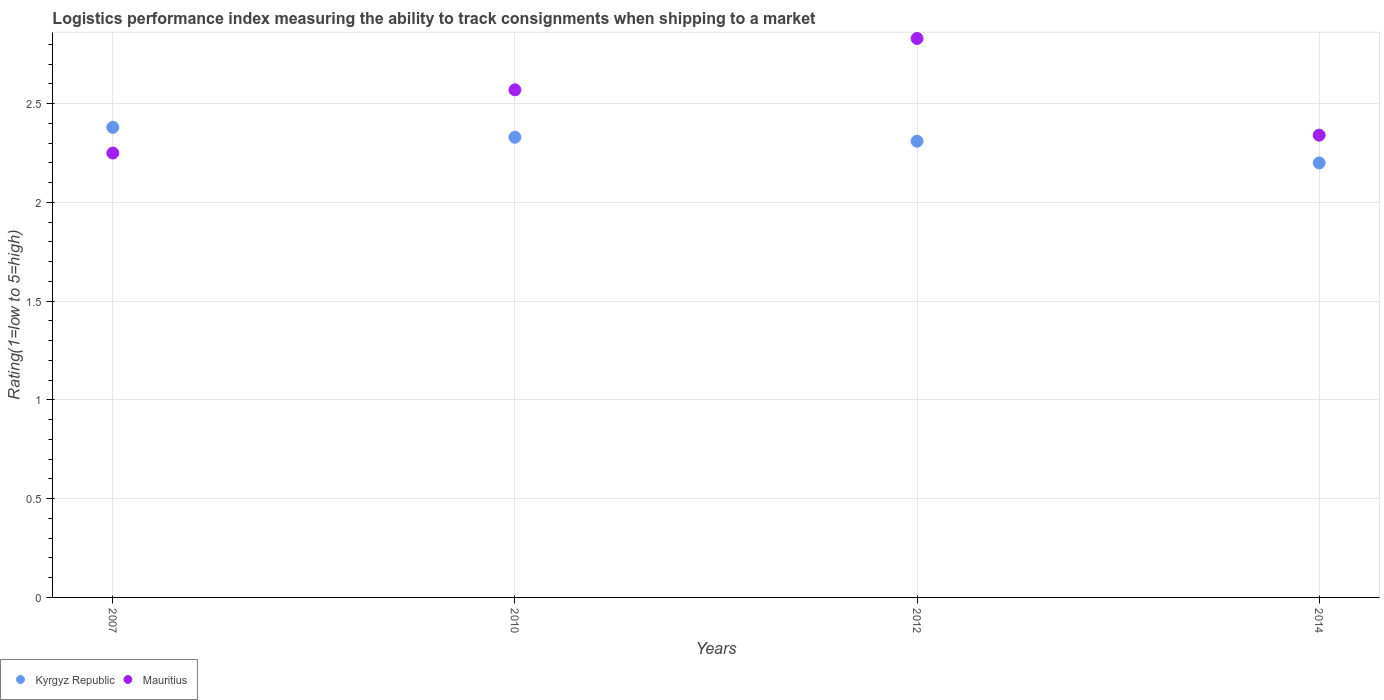Is the number of dotlines equal to the number of legend labels?
Keep it short and to the point. Yes. What is the Logistic performance index in Mauritius in 2007?
Your response must be concise. 2.25. Across all years, what is the maximum Logistic performance index in Kyrgyz Republic?
Ensure brevity in your answer.  2.38. Across all years, what is the minimum Logistic performance index in Kyrgyz Republic?
Your answer should be very brief. 2.2. In which year was the Logistic performance index in Kyrgyz Republic maximum?
Make the answer very short. 2007. In which year was the Logistic performance index in Mauritius minimum?
Provide a succinct answer. 2007. What is the total Logistic performance index in Mauritius in the graph?
Give a very brief answer. 9.99. What is the difference between the Logistic performance index in Kyrgyz Republic in 2010 and that in 2012?
Keep it short and to the point. 0.02. What is the difference between the Logistic performance index in Kyrgyz Republic in 2014 and the Logistic performance index in Mauritius in 2007?
Ensure brevity in your answer.  -0.05. What is the average Logistic performance index in Kyrgyz Republic per year?
Your answer should be very brief. 2.3. In the year 2014, what is the difference between the Logistic performance index in Kyrgyz Republic and Logistic performance index in Mauritius?
Give a very brief answer. -0.14. What is the ratio of the Logistic performance index in Mauritius in 2007 to that in 2012?
Give a very brief answer. 0.8. Is the Logistic performance index in Mauritius in 2012 less than that in 2014?
Your response must be concise. No. Is the difference between the Logistic performance index in Kyrgyz Republic in 2010 and 2012 greater than the difference between the Logistic performance index in Mauritius in 2010 and 2012?
Make the answer very short. Yes. What is the difference between the highest and the second highest Logistic performance index in Mauritius?
Your answer should be very brief. 0.26. What is the difference between the highest and the lowest Logistic performance index in Kyrgyz Republic?
Provide a succinct answer. 0.18. In how many years, is the Logistic performance index in Kyrgyz Republic greater than the average Logistic performance index in Kyrgyz Republic taken over all years?
Make the answer very short. 3. Does the Logistic performance index in Kyrgyz Republic monotonically increase over the years?
Your response must be concise. No. Is the Logistic performance index in Kyrgyz Republic strictly less than the Logistic performance index in Mauritius over the years?
Provide a succinct answer. No. How many dotlines are there?
Your answer should be compact. 2. How many years are there in the graph?
Provide a succinct answer. 4. Does the graph contain grids?
Make the answer very short. Yes. Where does the legend appear in the graph?
Provide a succinct answer. Bottom left. What is the title of the graph?
Give a very brief answer. Logistics performance index measuring the ability to track consignments when shipping to a market. What is the label or title of the Y-axis?
Give a very brief answer. Rating(1=low to 5=high). What is the Rating(1=low to 5=high) of Kyrgyz Republic in 2007?
Make the answer very short. 2.38. What is the Rating(1=low to 5=high) of Mauritius in 2007?
Your answer should be compact. 2.25. What is the Rating(1=low to 5=high) of Kyrgyz Republic in 2010?
Keep it short and to the point. 2.33. What is the Rating(1=low to 5=high) in Mauritius in 2010?
Your answer should be very brief. 2.57. What is the Rating(1=low to 5=high) of Kyrgyz Republic in 2012?
Keep it short and to the point. 2.31. What is the Rating(1=low to 5=high) of Mauritius in 2012?
Offer a terse response. 2.83. What is the Rating(1=low to 5=high) in Kyrgyz Republic in 2014?
Your answer should be very brief. 2.2. What is the Rating(1=low to 5=high) in Mauritius in 2014?
Make the answer very short. 2.34. Across all years, what is the maximum Rating(1=low to 5=high) of Kyrgyz Republic?
Offer a terse response. 2.38. Across all years, what is the maximum Rating(1=low to 5=high) in Mauritius?
Keep it short and to the point. 2.83. Across all years, what is the minimum Rating(1=low to 5=high) in Kyrgyz Republic?
Give a very brief answer. 2.2. Across all years, what is the minimum Rating(1=low to 5=high) of Mauritius?
Provide a short and direct response. 2.25. What is the total Rating(1=low to 5=high) of Kyrgyz Republic in the graph?
Make the answer very short. 9.22. What is the total Rating(1=low to 5=high) of Mauritius in the graph?
Give a very brief answer. 9.99. What is the difference between the Rating(1=low to 5=high) of Mauritius in 2007 and that in 2010?
Provide a short and direct response. -0.32. What is the difference between the Rating(1=low to 5=high) in Kyrgyz Republic in 2007 and that in 2012?
Your answer should be compact. 0.07. What is the difference between the Rating(1=low to 5=high) in Mauritius in 2007 and that in 2012?
Your answer should be very brief. -0.58. What is the difference between the Rating(1=low to 5=high) in Kyrgyz Republic in 2007 and that in 2014?
Offer a terse response. 0.18. What is the difference between the Rating(1=low to 5=high) of Mauritius in 2007 and that in 2014?
Ensure brevity in your answer.  -0.09. What is the difference between the Rating(1=low to 5=high) of Kyrgyz Republic in 2010 and that in 2012?
Offer a very short reply. 0.02. What is the difference between the Rating(1=low to 5=high) in Mauritius in 2010 and that in 2012?
Make the answer very short. -0.26. What is the difference between the Rating(1=low to 5=high) in Kyrgyz Republic in 2010 and that in 2014?
Provide a succinct answer. 0.13. What is the difference between the Rating(1=low to 5=high) in Mauritius in 2010 and that in 2014?
Give a very brief answer. 0.23. What is the difference between the Rating(1=low to 5=high) of Kyrgyz Republic in 2012 and that in 2014?
Your answer should be very brief. 0.11. What is the difference between the Rating(1=low to 5=high) in Mauritius in 2012 and that in 2014?
Keep it short and to the point. 0.49. What is the difference between the Rating(1=low to 5=high) of Kyrgyz Republic in 2007 and the Rating(1=low to 5=high) of Mauritius in 2010?
Make the answer very short. -0.19. What is the difference between the Rating(1=low to 5=high) of Kyrgyz Republic in 2007 and the Rating(1=low to 5=high) of Mauritius in 2012?
Give a very brief answer. -0.45. What is the difference between the Rating(1=low to 5=high) in Kyrgyz Republic in 2007 and the Rating(1=low to 5=high) in Mauritius in 2014?
Give a very brief answer. 0.04. What is the difference between the Rating(1=low to 5=high) in Kyrgyz Republic in 2010 and the Rating(1=low to 5=high) in Mauritius in 2014?
Keep it short and to the point. -0.01. What is the difference between the Rating(1=low to 5=high) in Kyrgyz Republic in 2012 and the Rating(1=low to 5=high) in Mauritius in 2014?
Ensure brevity in your answer.  -0.03. What is the average Rating(1=low to 5=high) of Kyrgyz Republic per year?
Your answer should be very brief. 2.31. What is the average Rating(1=low to 5=high) in Mauritius per year?
Offer a very short reply. 2.5. In the year 2007, what is the difference between the Rating(1=low to 5=high) of Kyrgyz Republic and Rating(1=low to 5=high) of Mauritius?
Ensure brevity in your answer.  0.13. In the year 2010, what is the difference between the Rating(1=low to 5=high) of Kyrgyz Republic and Rating(1=low to 5=high) of Mauritius?
Ensure brevity in your answer.  -0.24. In the year 2012, what is the difference between the Rating(1=low to 5=high) in Kyrgyz Republic and Rating(1=low to 5=high) in Mauritius?
Make the answer very short. -0.52. In the year 2014, what is the difference between the Rating(1=low to 5=high) of Kyrgyz Republic and Rating(1=low to 5=high) of Mauritius?
Offer a very short reply. -0.14. What is the ratio of the Rating(1=low to 5=high) of Kyrgyz Republic in 2007 to that in 2010?
Ensure brevity in your answer.  1.02. What is the ratio of the Rating(1=low to 5=high) in Mauritius in 2007 to that in 2010?
Ensure brevity in your answer.  0.88. What is the ratio of the Rating(1=low to 5=high) of Kyrgyz Republic in 2007 to that in 2012?
Keep it short and to the point. 1.03. What is the ratio of the Rating(1=low to 5=high) in Mauritius in 2007 to that in 2012?
Keep it short and to the point. 0.8. What is the ratio of the Rating(1=low to 5=high) of Kyrgyz Republic in 2007 to that in 2014?
Provide a short and direct response. 1.08. What is the ratio of the Rating(1=low to 5=high) of Mauritius in 2007 to that in 2014?
Ensure brevity in your answer.  0.96. What is the ratio of the Rating(1=low to 5=high) in Kyrgyz Republic in 2010 to that in 2012?
Offer a terse response. 1.01. What is the ratio of the Rating(1=low to 5=high) of Mauritius in 2010 to that in 2012?
Provide a short and direct response. 0.91. What is the ratio of the Rating(1=low to 5=high) of Kyrgyz Republic in 2010 to that in 2014?
Provide a short and direct response. 1.06. What is the ratio of the Rating(1=low to 5=high) in Mauritius in 2010 to that in 2014?
Ensure brevity in your answer.  1.1. What is the ratio of the Rating(1=low to 5=high) in Kyrgyz Republic in 2012 to that in 2014?
Offer a very short reply. 1.05. What is the ratio of the Rating(1=low to 5=high) of Mauritius in 2012 to that in 2014?
Give a very brief answer. 1.21. What is the difference between the highest and the second highest Rating(1=low to 5=high) of Kyrgyz Republic?
Provide a short and direct response. 0.05. What is the difference between the highest and the second highest Rating(1=low to 5=high) of Mauritius?
Ensure brevity in your answer.  0.26. What is the difference between the highest and the lowest Rating(1=low to 5=high) of Kyrgyz Republic?
Make the answer very short. 0.18. What is the difference between the highest and the lowest Rating(1=low to 5=high) of Mauritius?
Your answer should be compact. 0.58. 